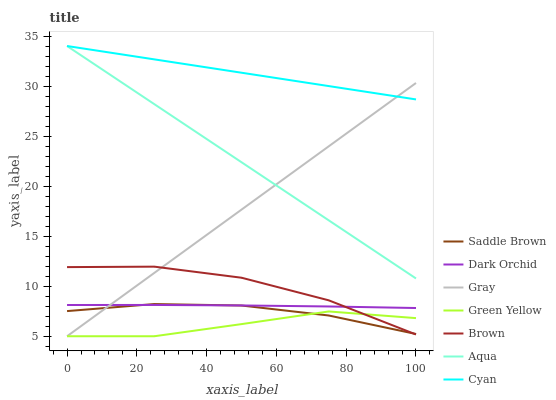Does Green Yellow have the minimum area under the curve?
Answer yes or no. Yes. Does Cyan have the maximum area under the curve?
Answer yes or no. Yes. Does Brown have the minimum area under the curve?
Answer yes or no. No. Does Brown have the maximum area under the curve?
Answer yes or no. No. Is Aqua the smoothest?
Answer yes or no. Yes. Is Brown the roughest?
Answer yes or no. Yes. Is Brown the smoothest?
Answer yes or no. No. Is Aqua the roughest?
Answer yes or no. No. Does Gray have the lowest value?
Answer yes or no. Yes. Does Brown have the lowest value?
Answer yes or no. No. Does Cyan have the highest value?
Answer yes or no. Yes. Does Brown have the highest value?
Answer yes or no. No. Is Brown less than Cyan?
Answer yes or no. Yes. Is Aqua greater than Saddle Brown?
Answer yes or no. Yes. Does Dark Orchid intersect Gray?
Answer yes or no. Yes. Is Dark Orchid less than Gray?
Answer yes or no. No. Is Dark Orchid greater than Gray?
Answer yes or no. No. Does Brown intersect Cyan?
Answer yes or no. No. 